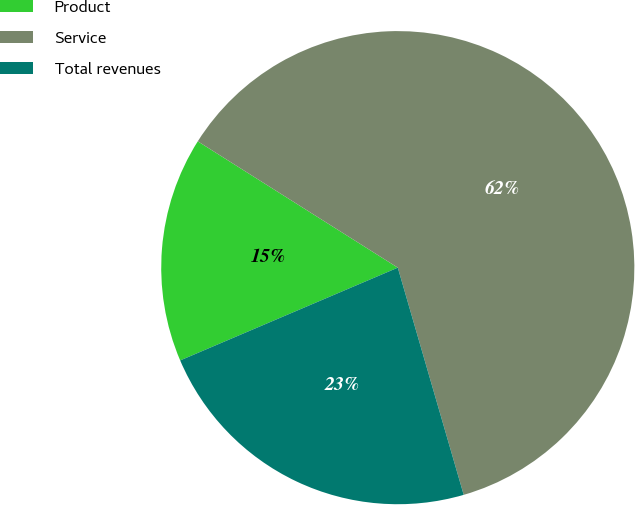<chart> <loc_0><loc_0><loc_500><loc_500><pie_chart><fcel>Product<fcel>Service<fcel>Total revenues<nl><fcel>15.38%<fcel>61.54%<fcel>23.08%<nl></chart> 